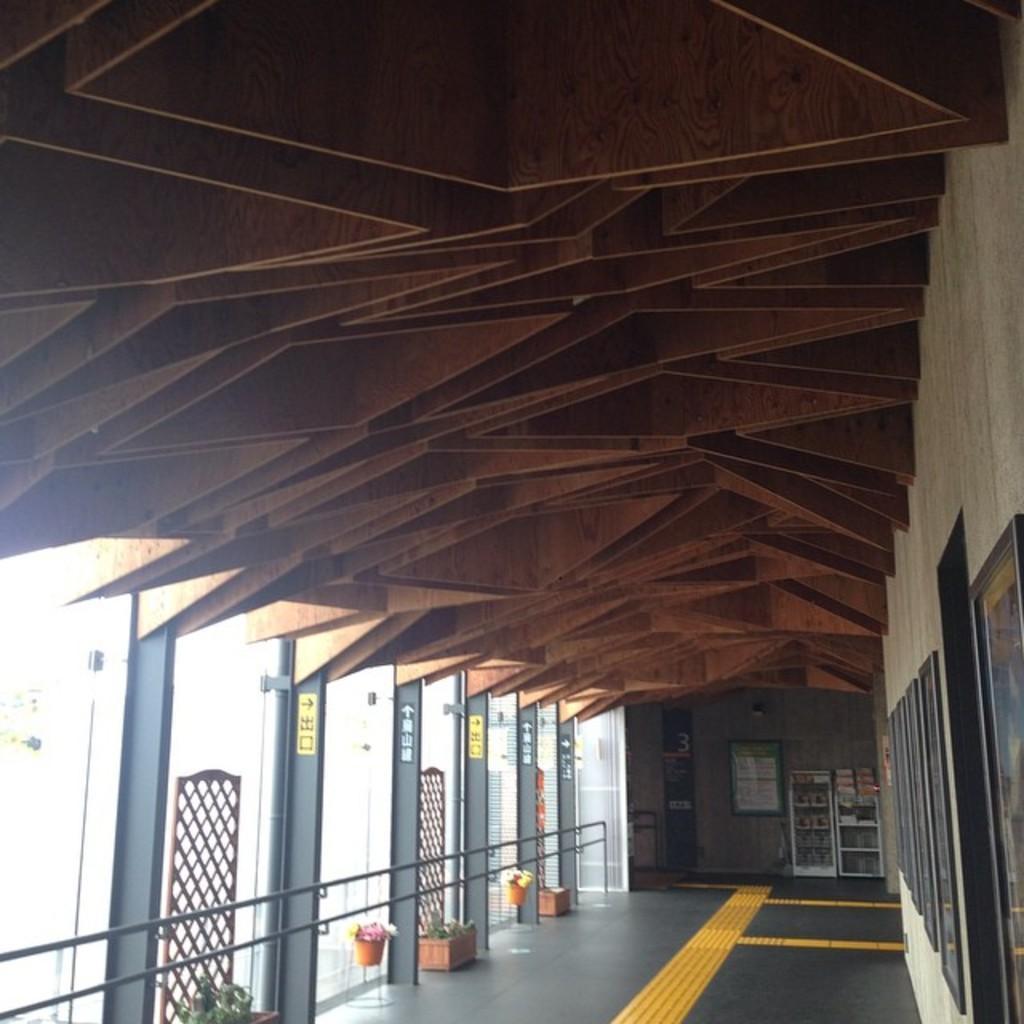Describe this image in one or two sentences. In this image I see the floor, plants in pots and I see few things over here and I see the wall on which there are frames and I see the pillars. 